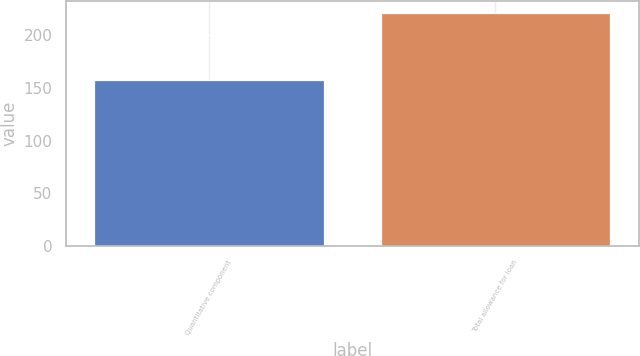<chart> <loc_0><loc_0><loc_500><loc_500><bar_chart><fcel>Quantitative component<fcel>Total allowance for loan<nl><fcel>157<fcel>221<nl></chart> 